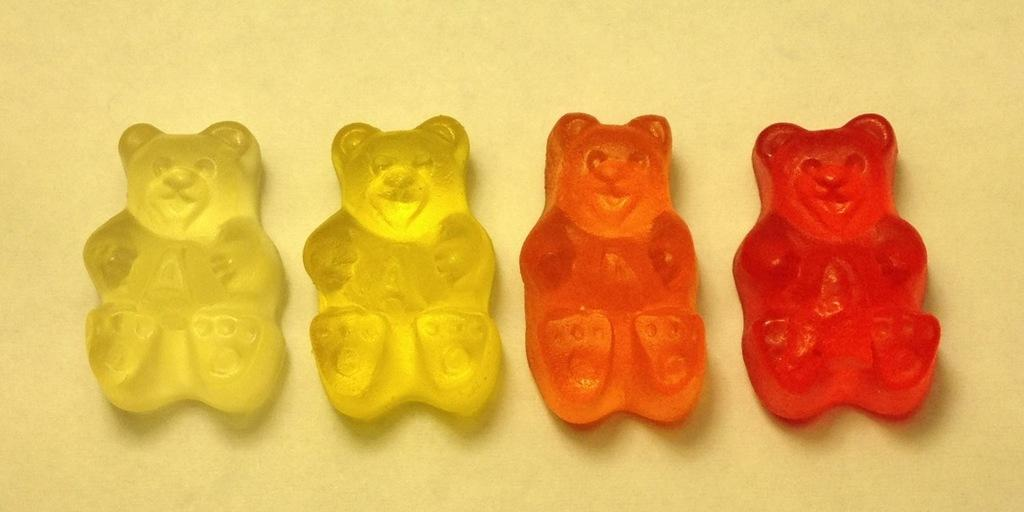What type of objects are present in the image that resemble candies? The objects in the image resemble candies and are in the shape of a teddy bear. Can you describe the shape of the candies in the image? The candies in the image are in the shape of a teddy bear. What is the value of the needle in the image? There is no needle present in the image. 